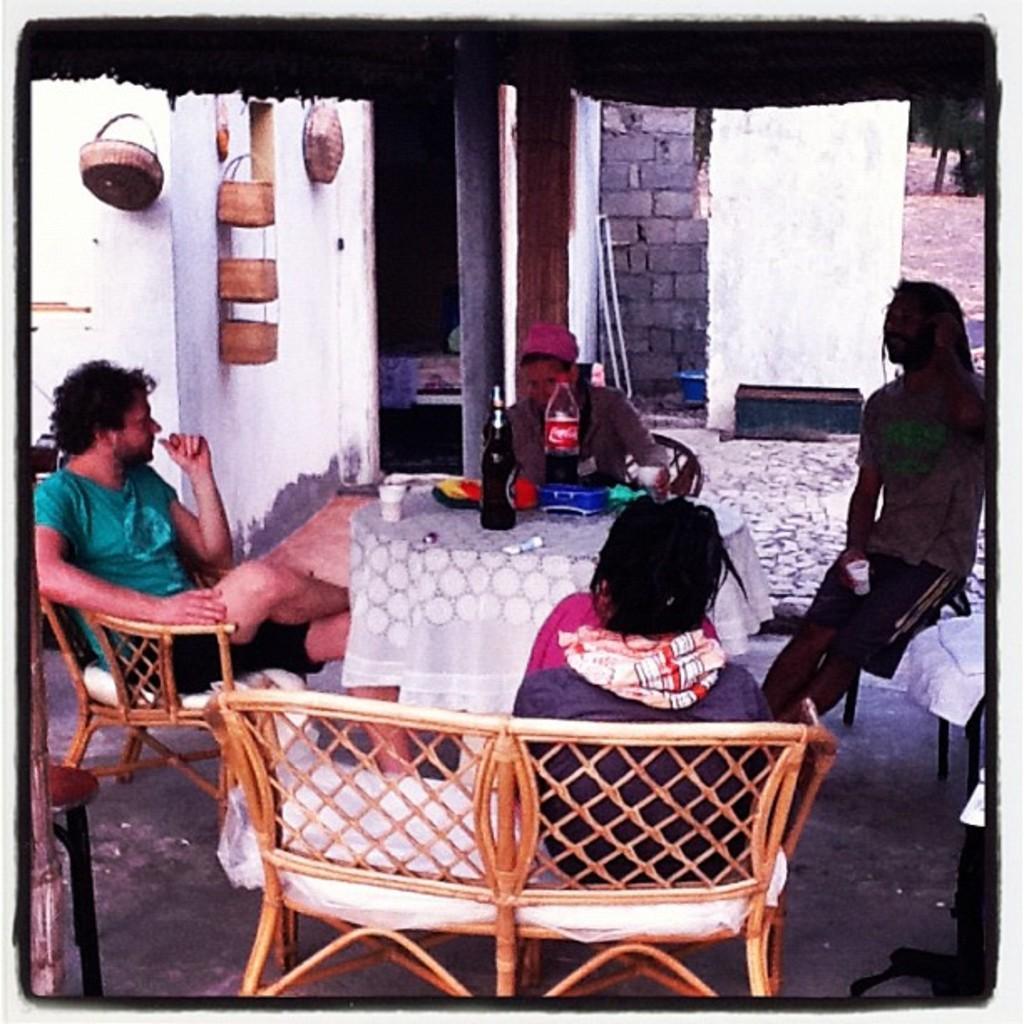In one or two sentences, can you explain what this image depicts? There are 4 people sitting on the chair at the table. On the table we can see water bottles,wine bottle,caps. In the background there is a wall. 